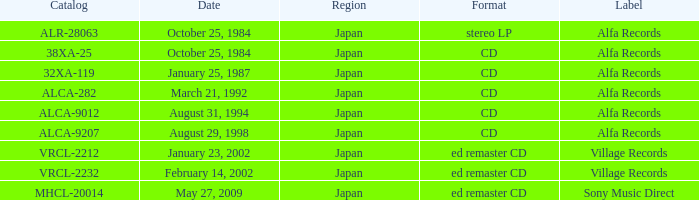What is the region of the release of a CD with catalog 32xa-119? Japan. 